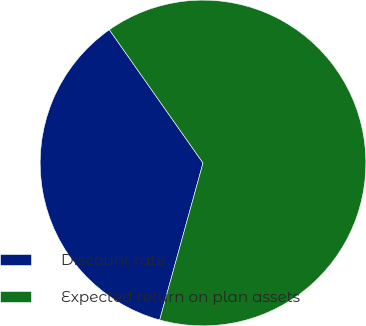Convert chart. <chart><loc_0><loc_0><loc_500><loc_500><pie_chart><fcel>Discount rate<fcel>Expected return on plan assets<nl><fcel>35.96%<fcel>64.04%<nl></chart> 